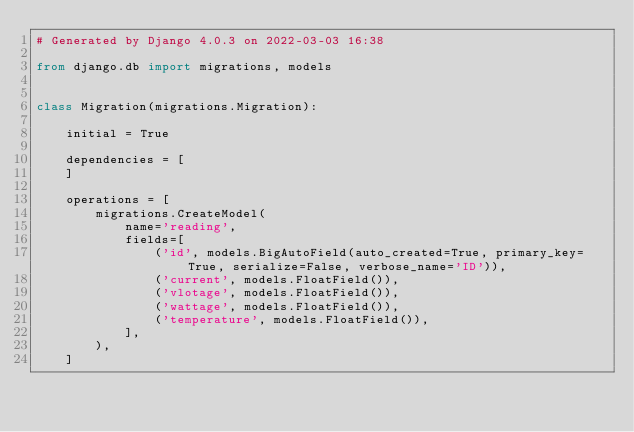<code> <loc_0><loc_0><loc_500><loc_500><_Python_># Generated by Django 4.0.3 on 2022-03-03 16:38

from django.db import migrations, models


class Migration(migrations.Migration):

    initial = True

    dependencies = [
    ]

    operations = [
        migrations.CreateModel(
            name='reading',
            fields=[
                ('id', models.BigAutoField(auto_created=True, primary_key=True, serialize=False, verbose_name='ID')),
                ('current', models.FloatField()),
                ('vlotage', models.FloatField()),
                ('wattage', models.FloatField()),
                ('temperature', models.FloatField()),
            ],
        ),
    ]
</code> 